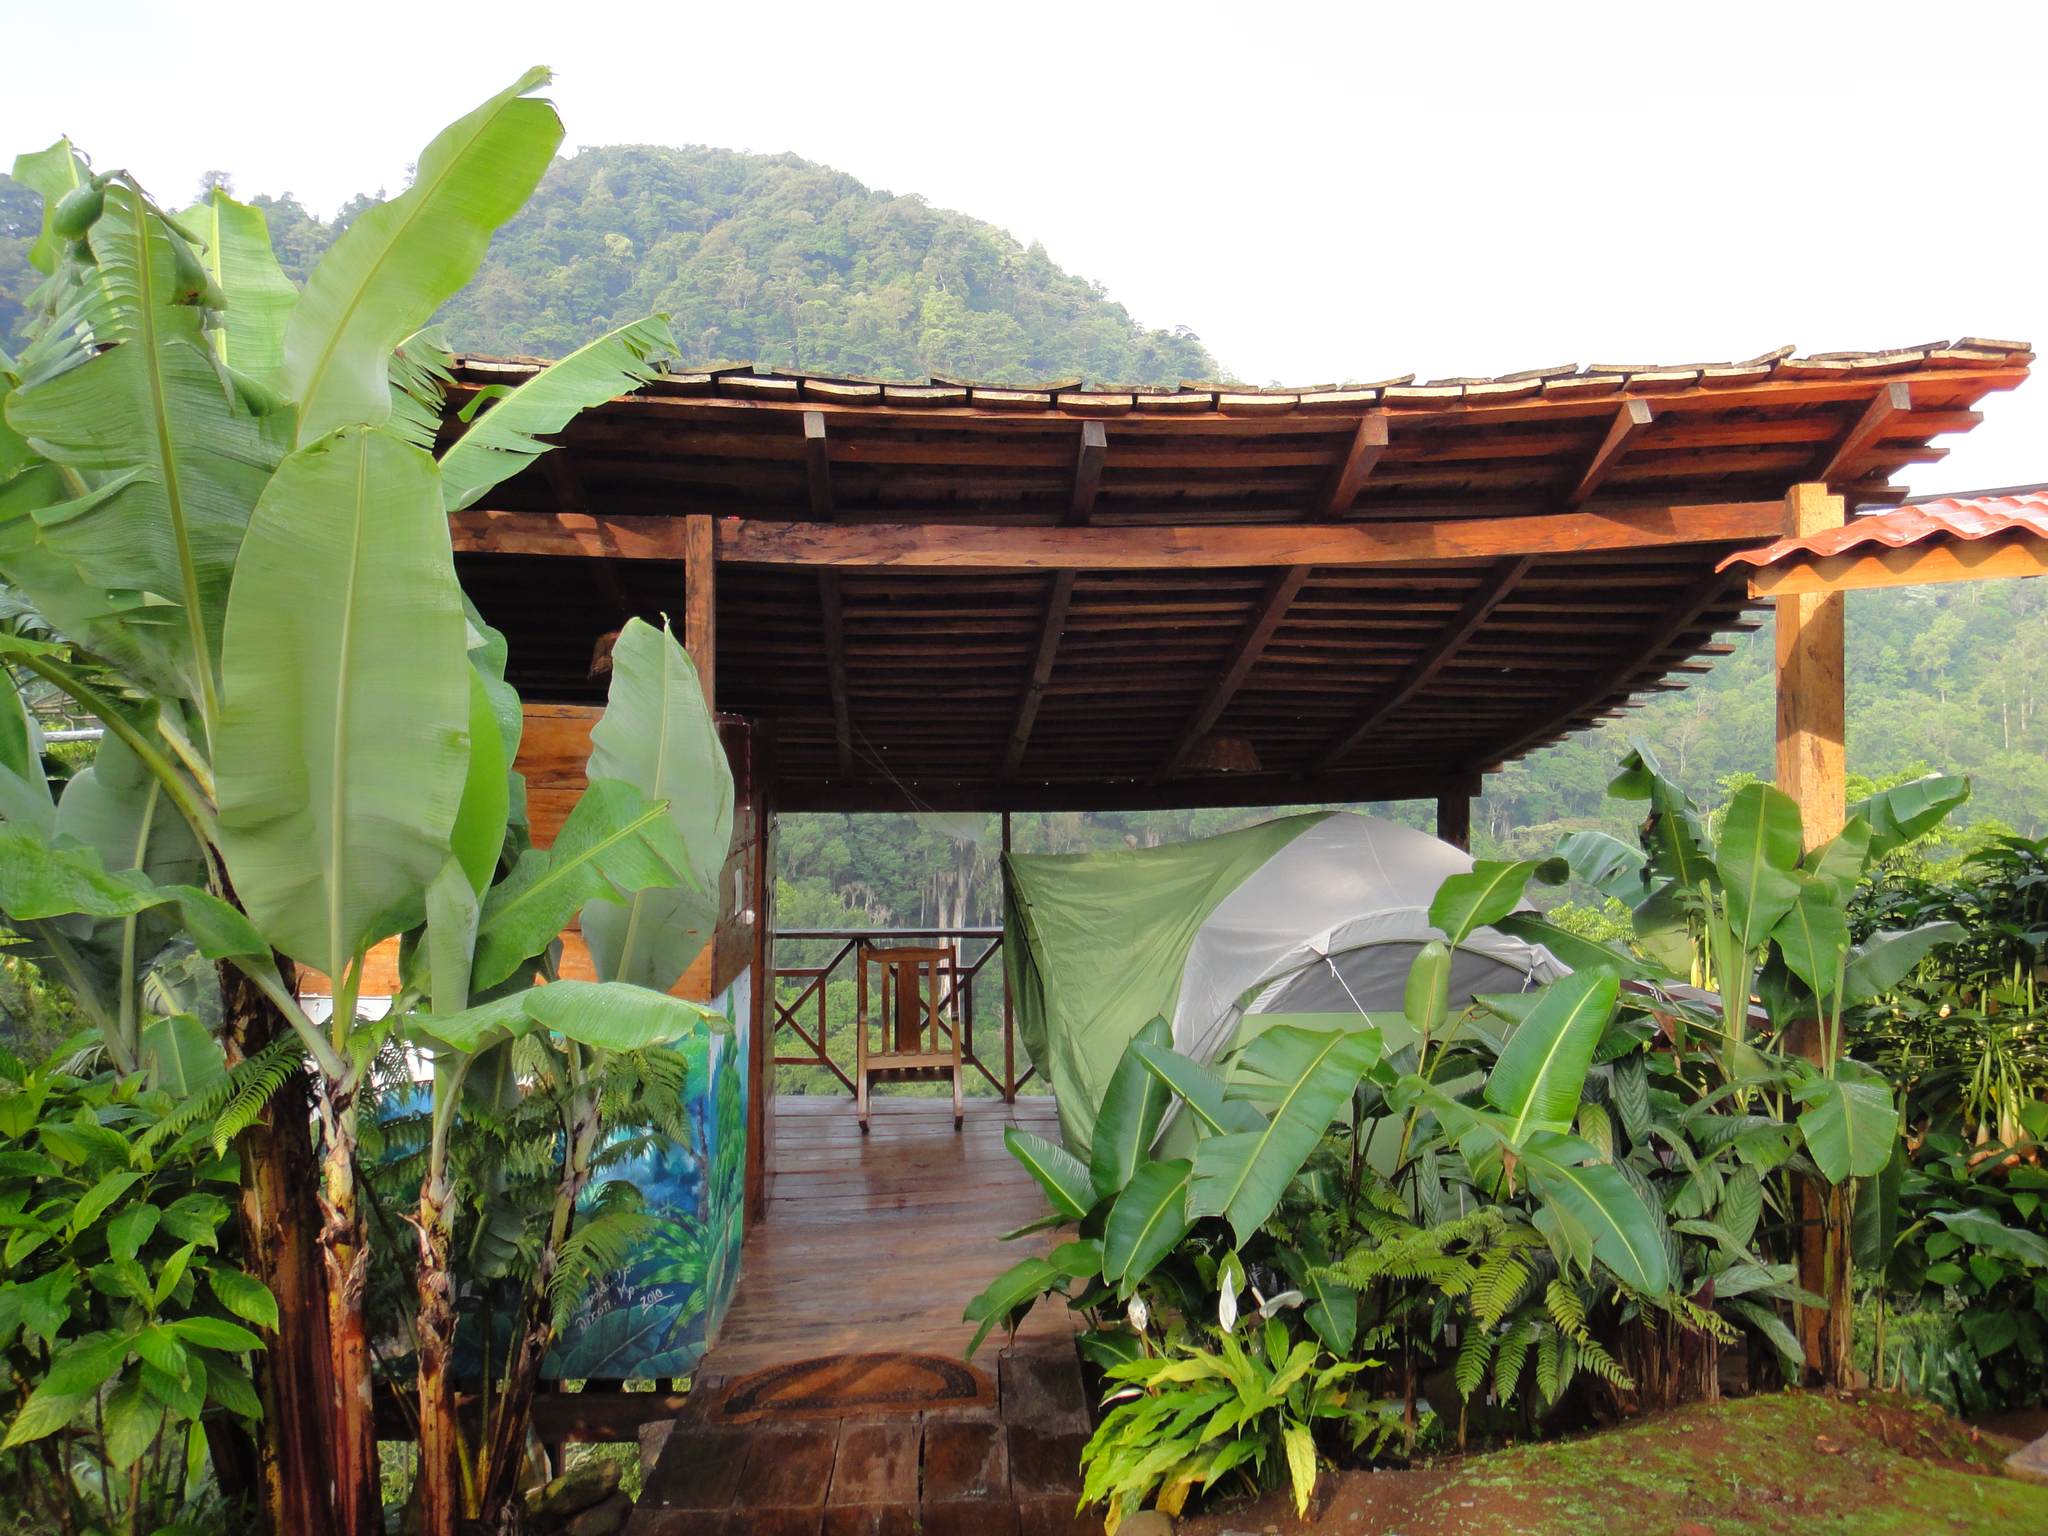Can you describe this image briefly? In this picture I can see there are plants here and there is a roof and there are chairs here. There are mountains in the backdrop and they are covered with trees and the sky is clear. 